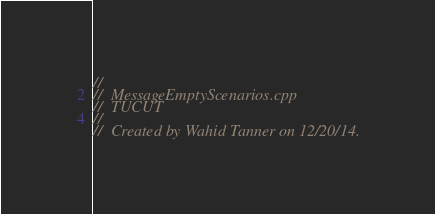Convert code to text. <code><loc_0><loc_0><loc_500><loc_500><_C++_>//
//  MessageEmptyScenarios.cpp
//  TUCUT
//
//  Created by Wahid Tanner on 12/20/14.</code> 